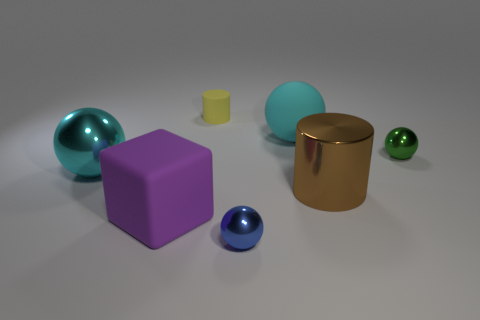Apart from the objects, what other features stand out in this composition? Beyond the objects themselves, the image features a plain, light gray background that gives a neutral setting, allowing the objects' colors and materials to stand out prominently. The lighting appears to be soft and diffused, resulting in gentle shadows cast by each object, creating a sense of depth and dimensionality in the otherwise minimalist scene. 